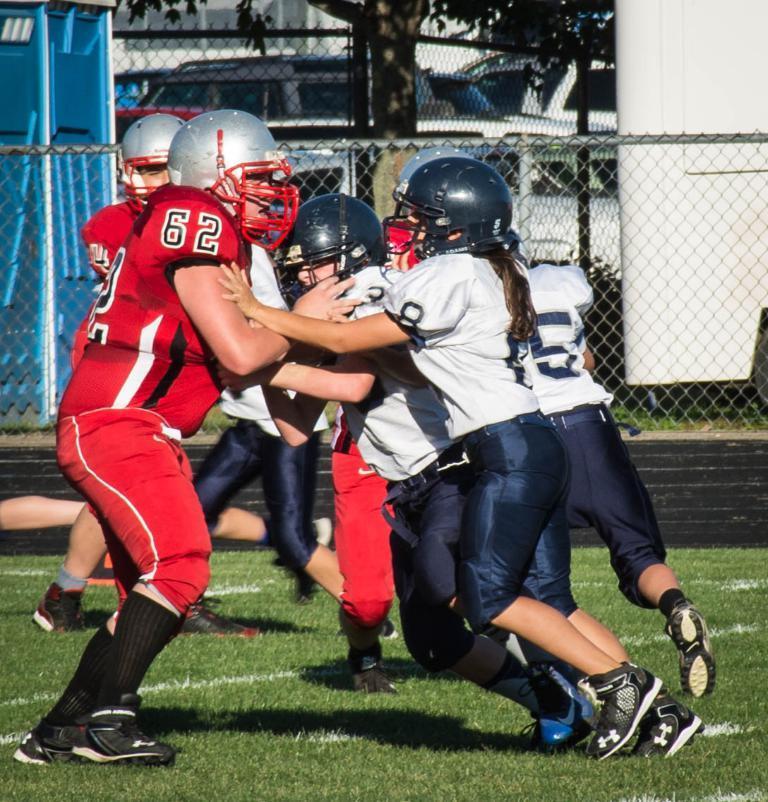Could you give a brief overview of what you see in this image? In this image, we can see people wearing sports dress and helmets and in the background, there is a tree and we can see vehicles and there are fences and boards. At the bottom, there is ground. 